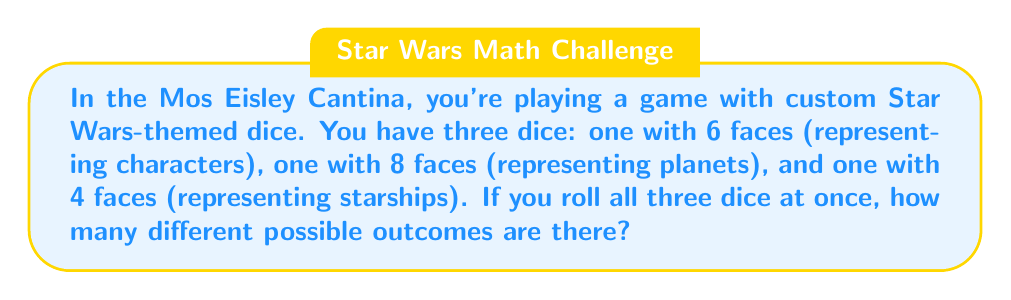Solve this math problem. Let's approach this step-by-step:

1) First, we need to understand what the question is asking. We're looking for the total number of possible outcomes when rolling three different dice simultaneously.

2) In combinatorics, when we have independent events (like rolling different dice), we use the multiplication principle. This principle states that if we have $m$ ways of doing something and $n$ ways of doing another thing, there are $m \times n$ ways of doing both.

3) Let's break it down for each die:
   - The character die has 6 faces: $6$ possible outcomes
   - The planet die has 8 faces: $8$ possible outcomes
   - The starship die has 4 faces: $4$ possible outcomes

4) Now, we apply the multiplication principle. The total number of possible outcomes is:

   $$ 6 \times 8 \times 4 $$

5) Let's calculate this:
   $$ 6 \times 8 \times 4 = 48 \times 4 = 192 $$

Therefore, there are 192 different possible outcomes when rolling these three Star Wars-themed dice together.
Answer: 192 